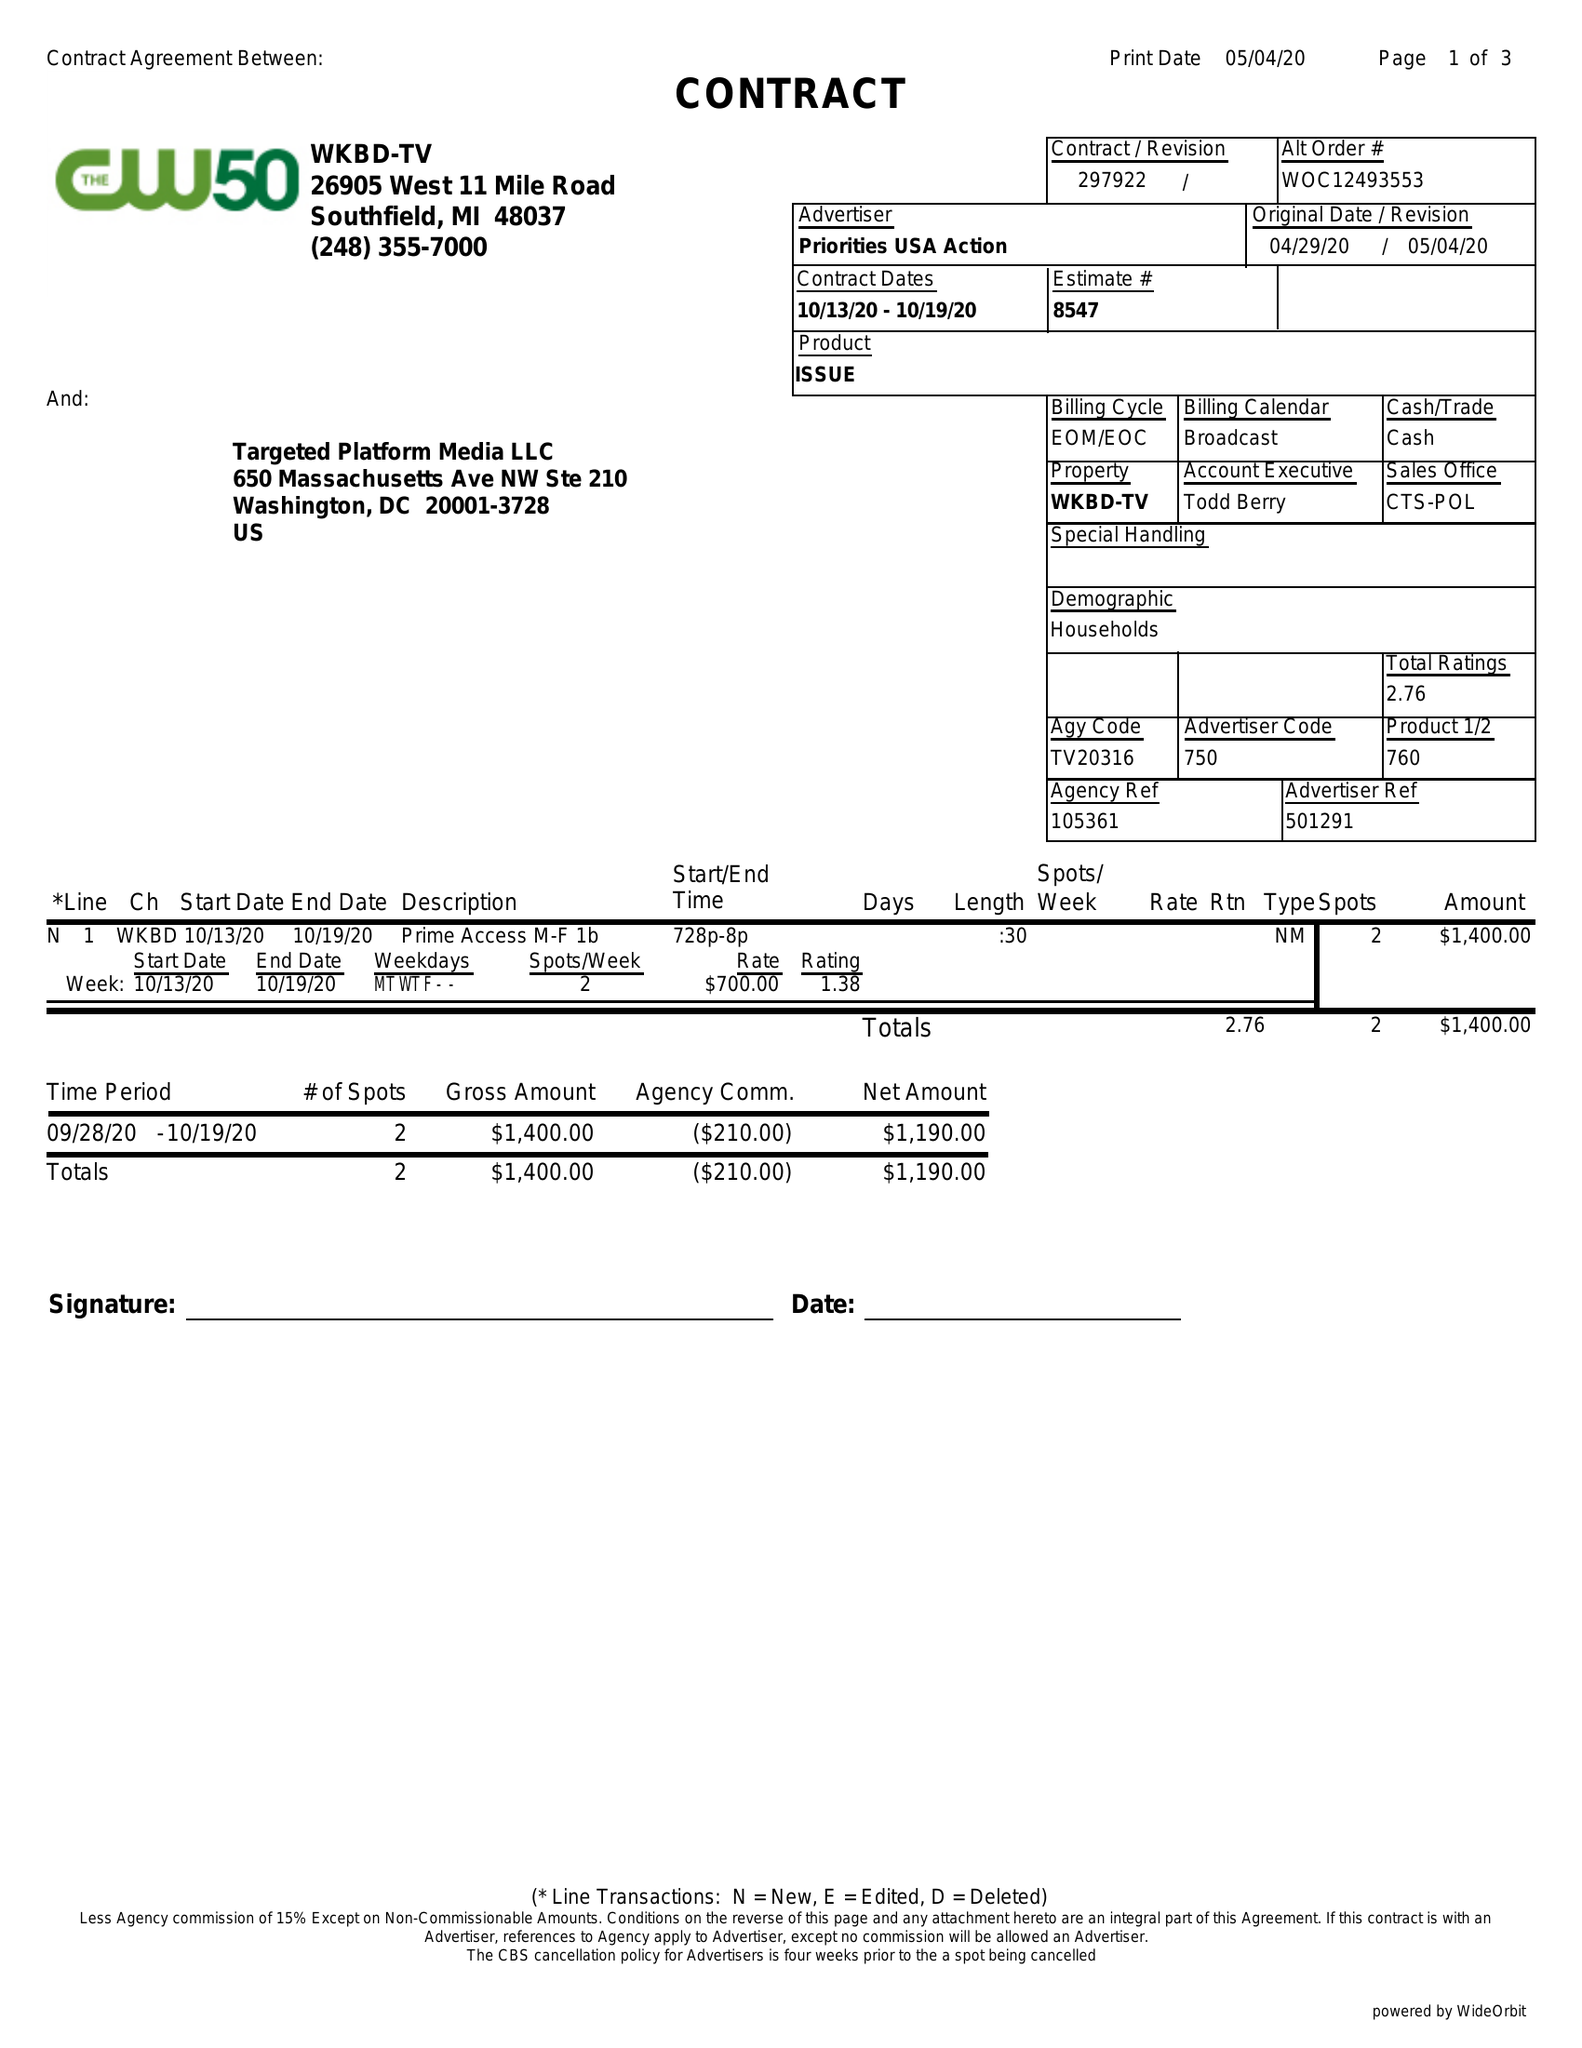What is the value for the advertiser?
Answer the question using a single word or phrase. PRIORITIES USA ACTION 